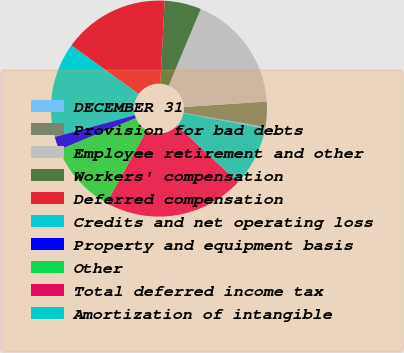<chart> <loc_0><loc_0><loc_500><loc_500><pie_chart><fcel>DECEMBER 31<fcel>Provision for bad debts<fcel>Employee retirement and other<fcel>Workers' compensation<fcel>Deferred compensation<fcel>Credits and net operating loss<fcel>Property and equipment basis<fcel>Other<fcel>Total deferred income tax<fcel>Amortization of intangible<nl><fcel>0.27%<fcel>3.75%<fcel>17.64%<fcel>5.48%<fcel>15.91%<fcel>14.17%<fcel>2.01%<fcel>10.69%<fcel>21.12%<fcel>8.96%<nl></chart> 